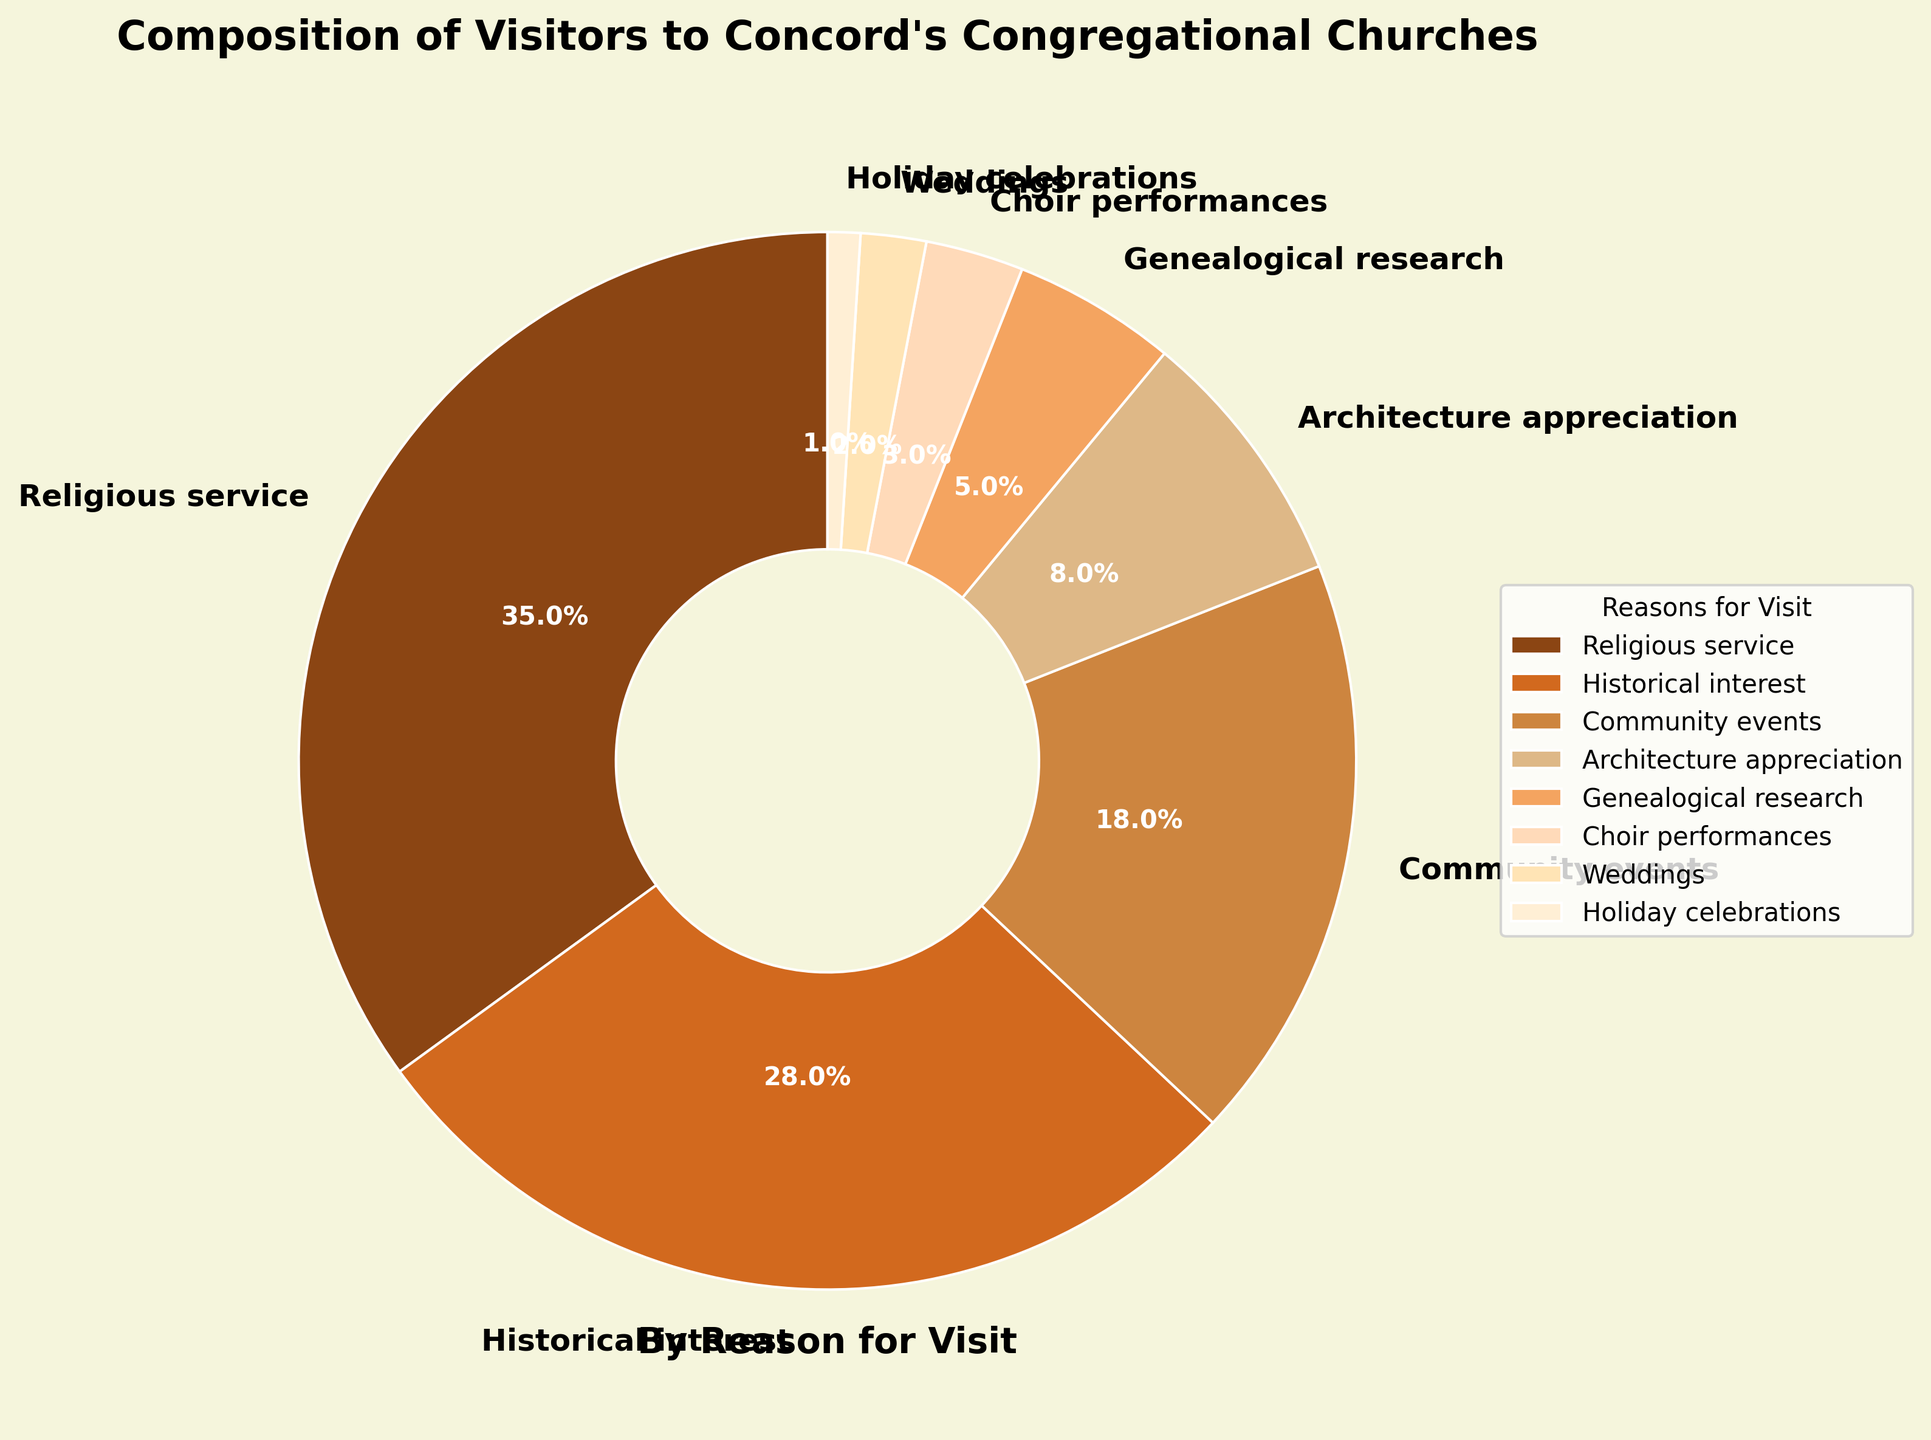What are the two most common reasons for visiting Concord's congregational churches? The two slices of the pie chart with the largest percentages represent the two most common reasons. These are "Religious service" at 35% and "Historical interest" at 28%.
Answer: Religious service and Historical interest What's the total percentage of visitors who come for community events, weddings, and holiday celebrations? Sum up the percentages of visitors for "Community events" (18%), "Weddings" (2%), and "Holiday celebrations" (1%). The total is 18% + 2% + 1% = 21%.
Answer: 21% Which reasons for visiting have a smaller percentage than Architecture appreciation? Compare the percentages of all reasons to "Architecture appreciation" (8%). The reasons with smaller percentages are "Genealogical research" (5%), "Choir performances" (3%), "Weddings" (2%), and "Holiday celebrations" (1%).
Answer: Genealogical research, Choir performances, Weddings, Holiday celebrations How much larger is the percentage of visitors who come for religious services than for historical interest? Subtract the percentage of visitors for "Historical interest" (28%) from the percentage for "Religious service" (35%). The difference is 35% - 28% = 7%.
Answer: 7% Which reason has the third largest percentage of visitors? Identify the third largest slice in the pie chart. The reasons in order are "Religious service" (35%), "Historical interest" (28%), and "Community events" (18%). Thus, "Community events" is the third largest.
Answer: Community events What percentage of visitors come for reasons related to performances (Choir performances and Weddings)? Sum the percentages of visitors for "Choir performances" (3%) and "Weddings" (2%). The total is 3% + 2% = 5%.
Answer: 5% Which reason for visiting, "Genealogical research" or "Choir performances," has a higher percentage? Compare the percentages of "Genealogical research" (5%) and "Choir performances" (3%). "Genealogical research" has a higher percentage.
Answer: Genealogical research If the total number of visitors is 10,000, how many visitors come for historical interest? Calculate 28% of 10,000. The number of visitors is 0.28 * 10,000 = 2,800.
Answer: 2,800 visitors Out of all the reasons listed, how many have percentages below 10%? Identify the slices with percentages less than 10%. These reasons are: "Architecture appreciation" (8%), "Genealogical research" (5%), "Choir performances" (3%), "Weddings" (2%), and "Holiday celebrations" (1%), totaling 5 reasons.
Answer: 5 reasons 